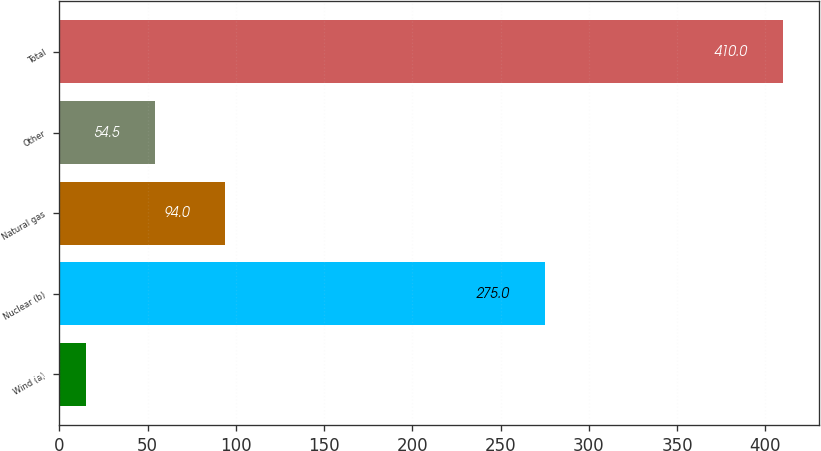Convert chart. <chart><loc_0><loc_0><loc_500><loc_500><bar_chart><fcel>Wind (a)<fcel>Nuclear (b)<fcel>Natural gas<fcel>Other<fcel>Total<nl><fcel>15<fcel>275<fcel>94<fcel>54.5<fcel>410<nl></chart> 